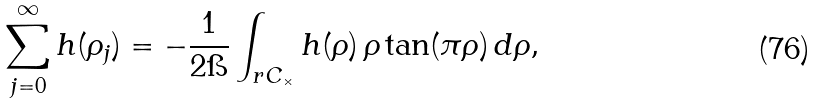Convert formula to latex. <formula><loc_0><loc_0><loc_500><loc_500>\sum _ { j = 0 } ^ { \infty } h ( \rho _ { j } ) = - \frac { 1 } { 2 \i } \int _ { r C _ { \times } } h ( \rho ) \, \rho \tan ( \pi \rho ) \, d \rho ,</formula> 